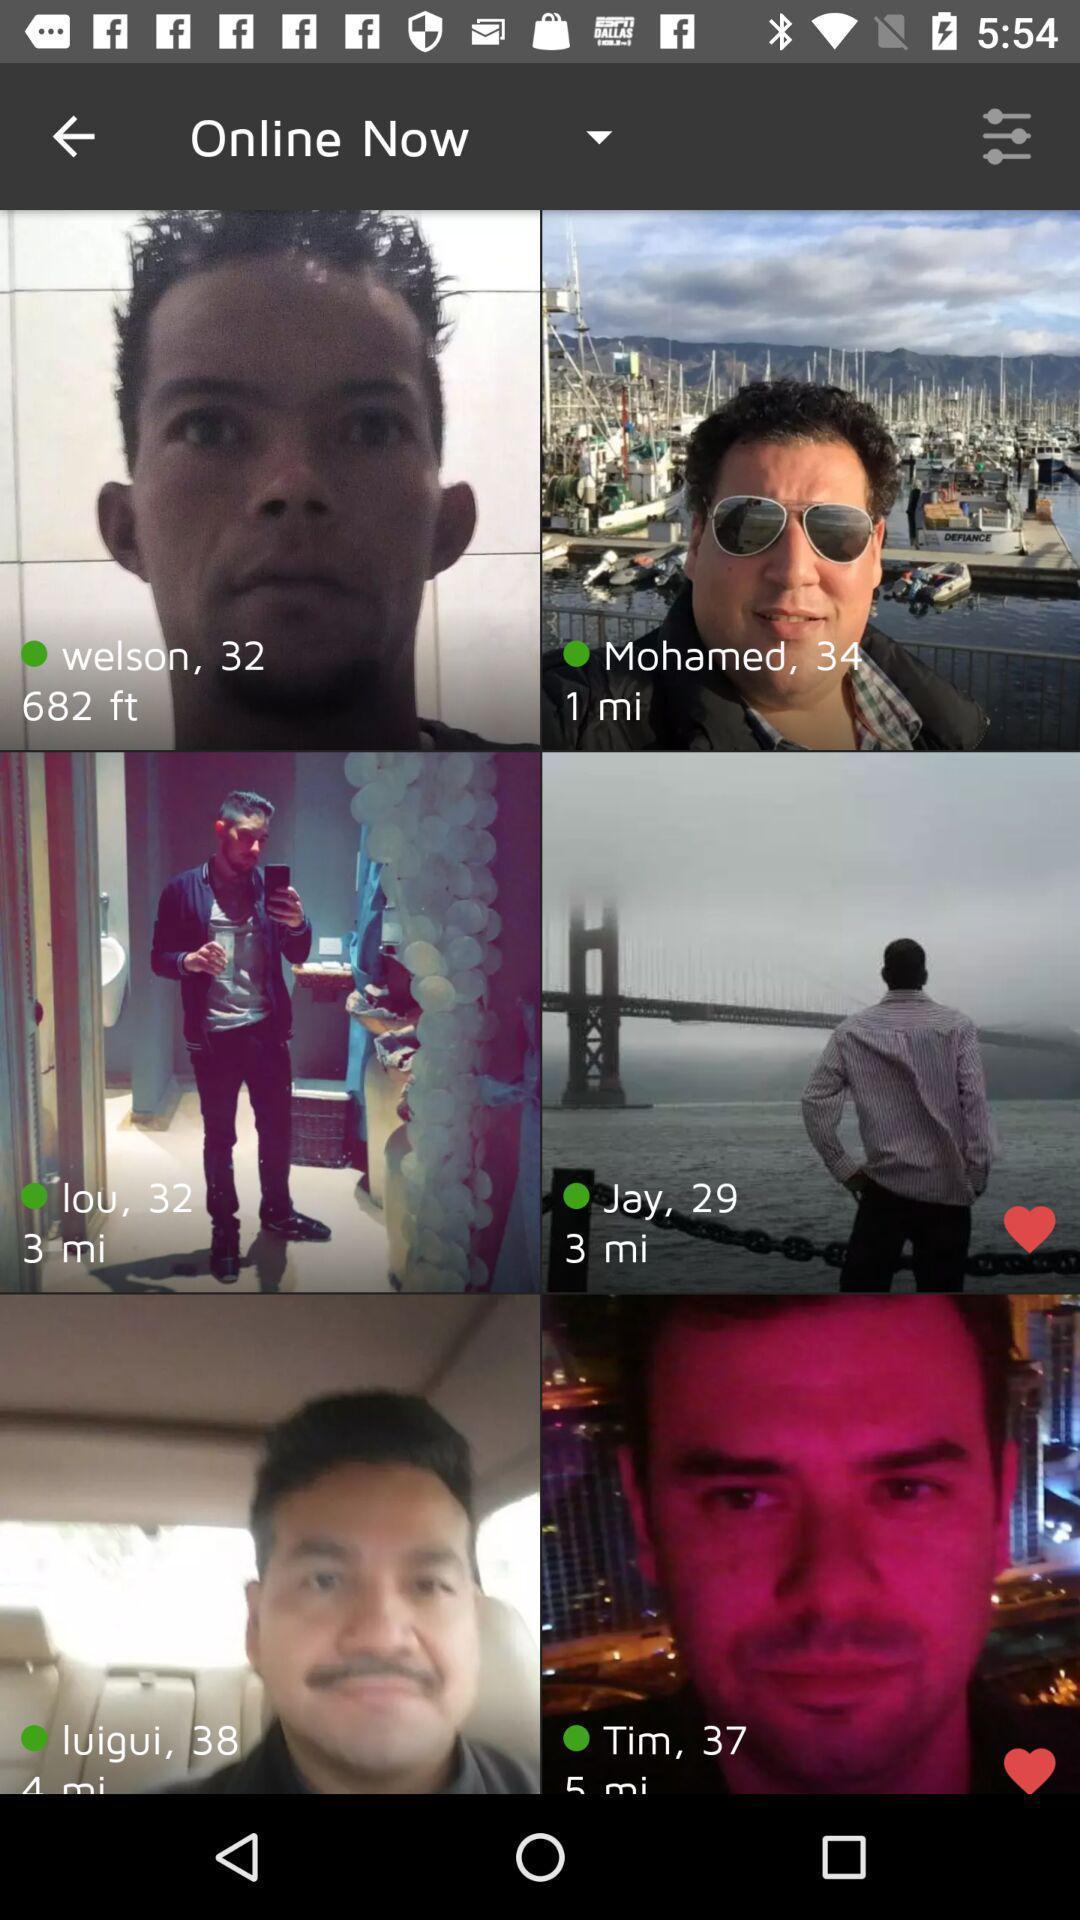Describe the visual elements of this screenshot. Page showing profiles of online people of a social app. 